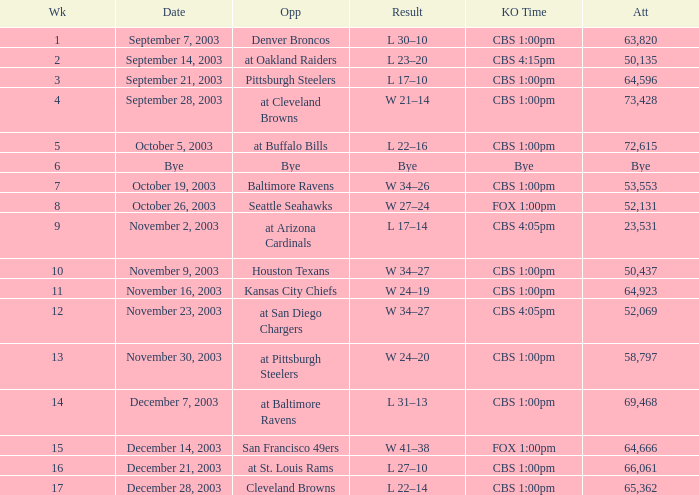What was the result of the game played on November 23, 2003? W 34–27. 